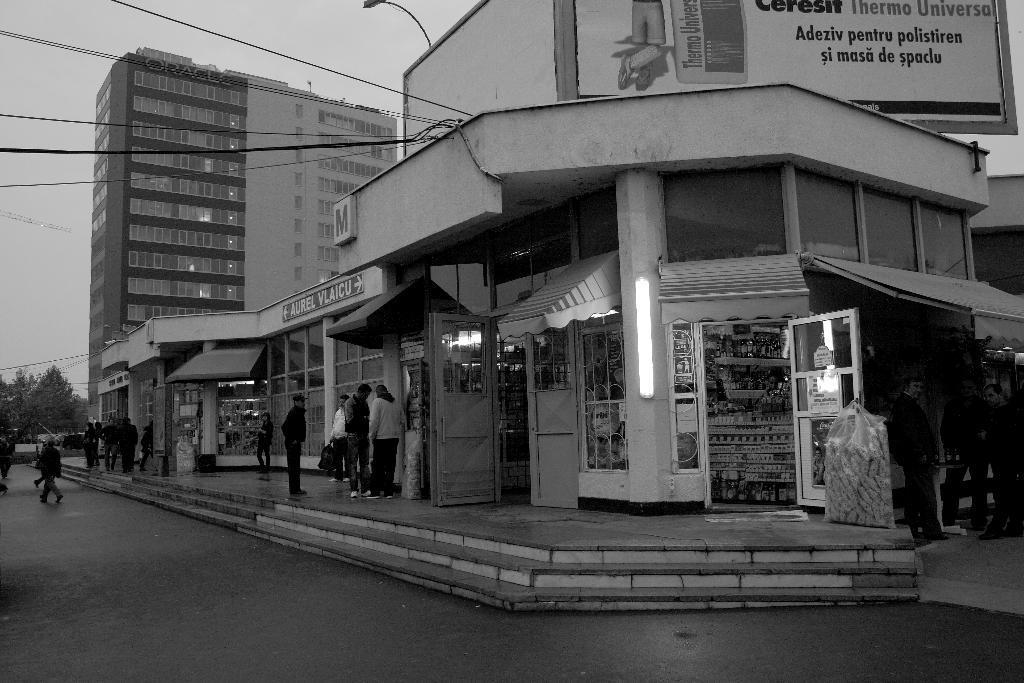Please provide a concise description of this image. In this image I see few trees in the background, a building and a number of shops and people on the paths and near the shops. 